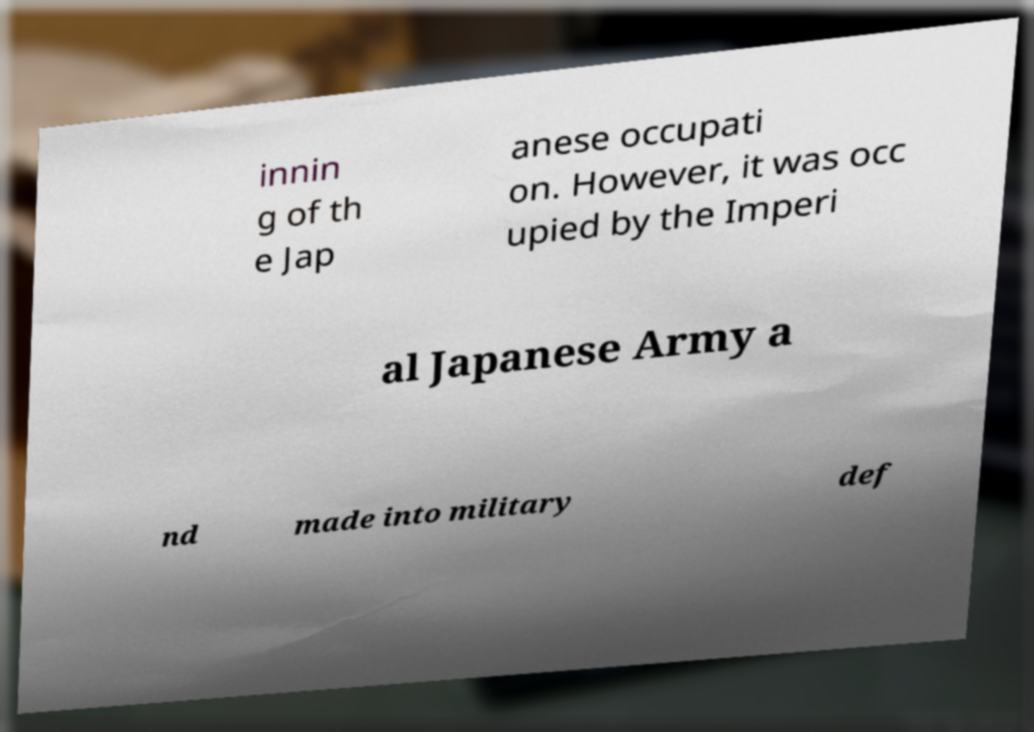For documentation purposes, I need the text within this image transcribed. Could you provide that? innin g of th e Jap anese occupati on. However, it was occ upied by the Imperi al Japanese Army a nd made into military def 